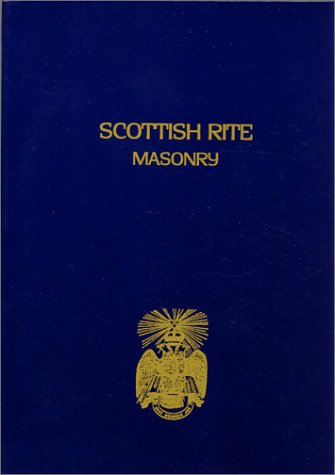What type of book is this? This book falls under the 'Religion & Spirituality' category, indoctrinating detailed aspects of Scottish Freemasonry. 